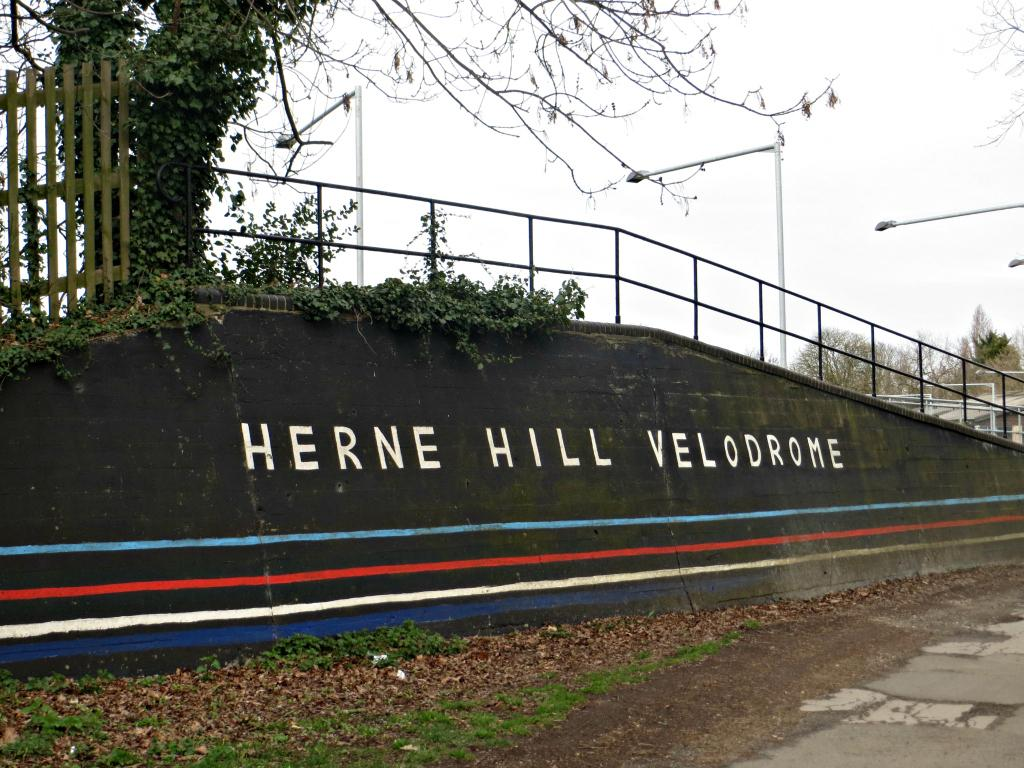<image>
Provide a brief description of the given image. a Herne williams velodrome that is next to the ground 